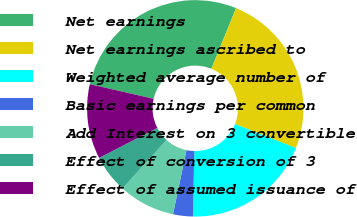<chart> <loc_0><loc_0><loc_500><loc_500><pie_chart><fcel>Net earnings<fcel>Net earnings ascribed to<fcel>Weighted average number of<fcel>Basic earnings per common<fcel>Add Interest on 3 convertible<fcel>Effect of conversion of 3<fcel>Effect of assumed issuance of<nl><fcel>27.57%<fcel>24.83%<fcel>19.36%<fcel>2.96%<fcel>8.43%<fcel>5.69%<fcel>11.16%<nl></chart> 